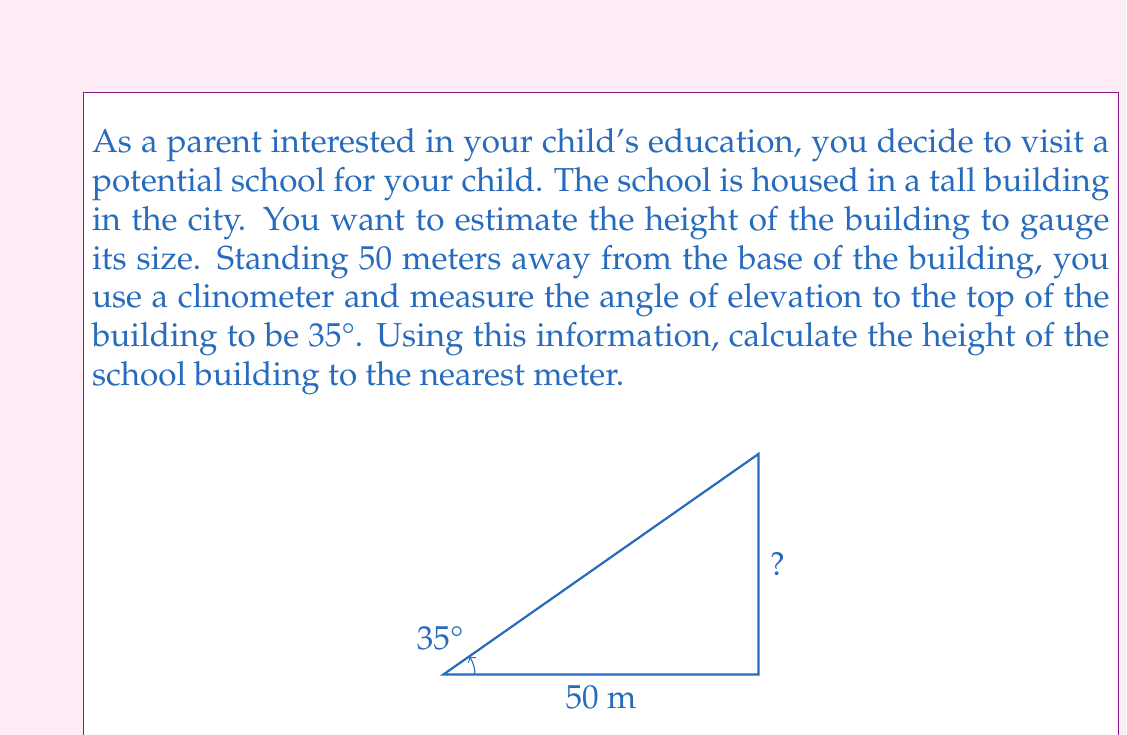Could you help me with this problem? To solve this problem, we can use trigonometry, specifically the tangent function. Let's break it down step-by-step:

1) In a right-angled triangle, tangent of an angle is the ratio of the opposite side to the adjacent side.

2) In our case:
   - The angle of elevation is 35°
   - The adjacent side (distance from you to the building) is 50 meters
   - The opposite side is the height of the building, which we need to find

3) Let's call the height of the building $h$. We can write the equation:

   $$\tan(35°) = \frac{h}{50}$$

4) To find $h$, we multiply both sides by 50:

   $$h = 50 \tan(35°)$$

5) Now, let's calculate this:
   
   $$h = 50 \times \tan(35°)$$
   $$h = 50 \times 0.7002$$
   $$h = 35.01$$

6) Rounding to the nearest meter as requested:

   $$h \approx 35 \text{ meters}$$

Thus, the height of the school building is approximately 35 meters.
Answer: The height of the school building is approximately 35 meters. 